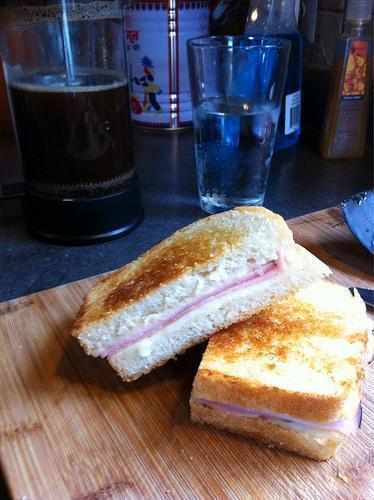How many sandwich halves are there?
Give a very brief answer. 2. 